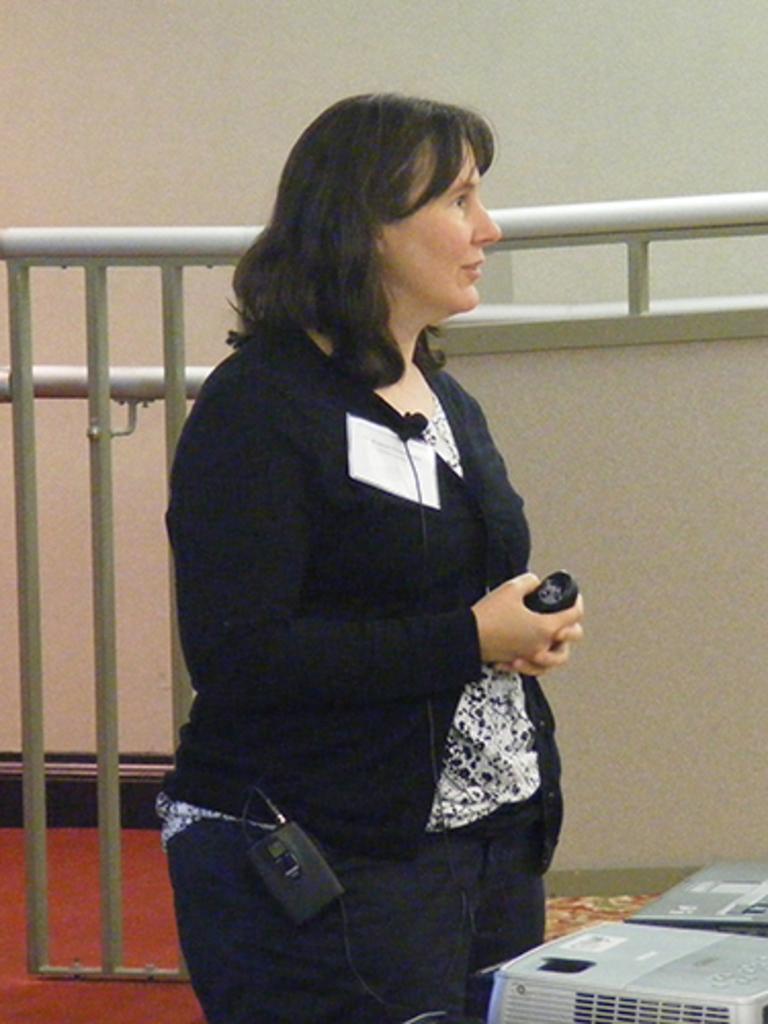Can you describe this image briefly? In this picture we can see a woman is standing and holding something, it looks like a projector at the right bottom, in the background there is a wall, we can see metal rods in the middle. 